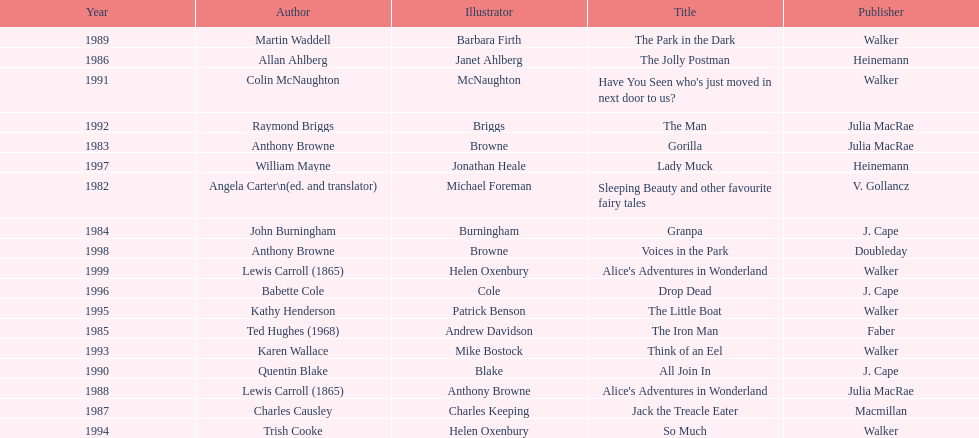What is the difference in years between the publication of angela carter's and anthony browne's titles? 1. Can you parse all the data within this table? {'header': ['Year', 'Author', 'Illustrator', 'Title', 'Publisher'], 'rows': [['1989', 'Martin Waddell', 'Barbara Firth', 'The Park in the Dark', 'Walker'], ['1986', 'Allan Ahlberg', 'Janet Ahlberg', 'The Jolly Postman', 'Heinemann'], ['1991', 'Colin McNaughton', 'McNaughton', "Have You Seen who's just moved in next door to us?", 'Walker'], ['1992', 'Raymond Briggs', 'Briggs', 'The Man', 'Julia MacRae'], ['1983', 'Anthony Browne', 'Browne', 'Gorilla', 'Julia MacRae'], ['1997', 'William Mayne', 'Jonathan Heale', 'Lady Muck', 'Heinemann'], ['1982', 'Angela Carter\\n(ed. and translator)', 'Michael Foreman', 'Sleeping Beauty and other favourite fairy tales', 'V. Gollancz'], ['1984', 'John Burningham', 'Burningham', 'Granpa', 'J. Cape'], ['1998', 'Anthony Browne', 'Browne', 'Voices in the Park', 'Doubleday'], ['1999', 'Lewis Carroll (1865)', 'Helen Oxenbury', "Alice's Adventures in Wonderland", 'Walker'], ['1996', 'Babette Cole', 'Cole', 'Drop Dead', 'J. Cape'], ['1995', 'Kathy Henderson', 'Patrick Benson', 'The Little Boat', 'Walker'], ['1985', 'Ted Hughes (1968)', 'Andrew Davidson', 'The Iron Man', 'Faber'], ['1993', 'Karen Wallace', 'Mike Bostock', 'Think of an Eel', 'Walker'], ['1990', 'Quentin Blake', 'Blake', 'All Join In', 'J. Cape'], ['1988', 'Lewis Carroll (1865)', 'Anthony Browne', "Alice's Adventures in Wonderland", 'Julia MacRae'], ['1987', 'Charles Causley', 'Charles Keeping', 'Jack the Treacle Eater', 'Macmillan'], ['1994', 'Trish Cooke', 'Helen Oxenbury', 'So Much', 'Walker']]} 